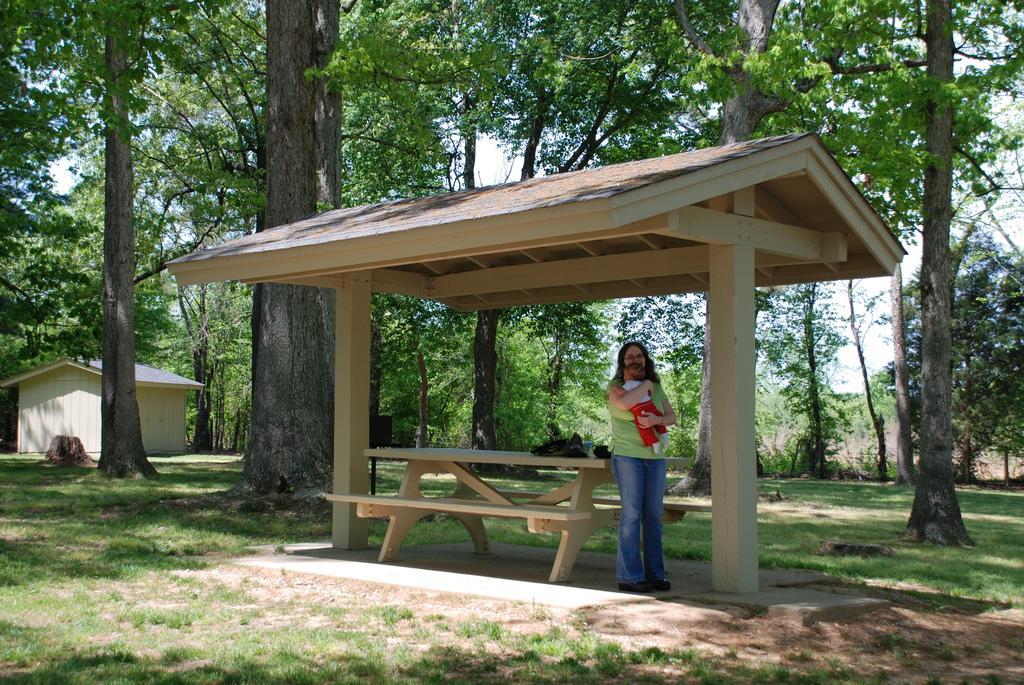Could you give a brief overview of what you see in this image? In the center of the image we can see a woman is standing and she is holding a kid. In the background, we can see the sky, trees, grass, sheds and a few other objects. 